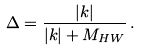Convert formula to latex. <formula><loc_0><loc_0><loc_500><loc_500>\Delta = \frac { | { k } | } { | { k } | + M _ { H W } } \, .</formula> 